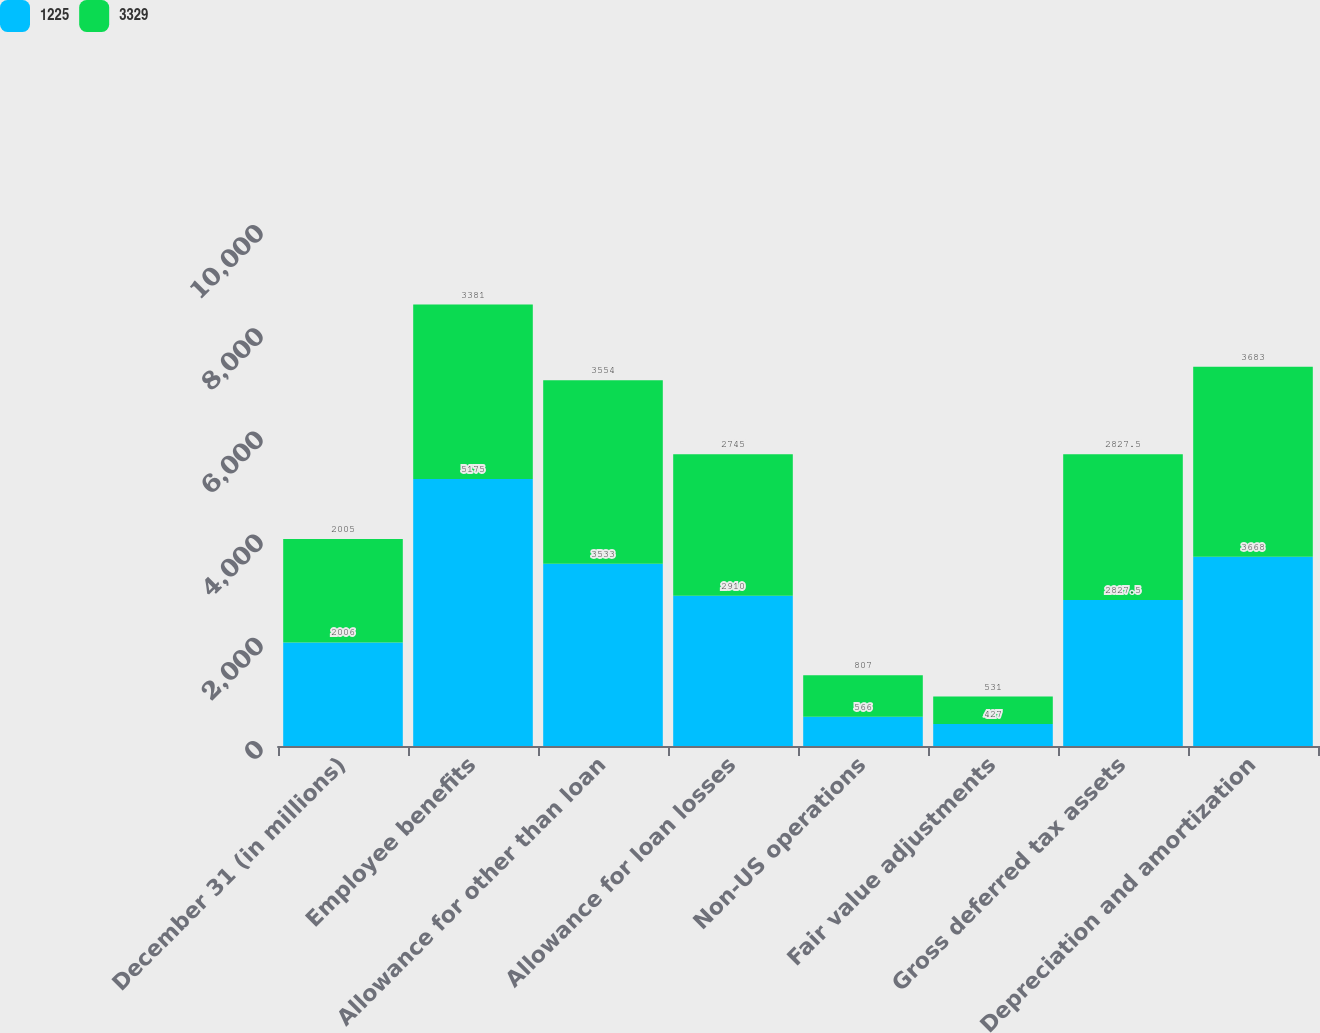<chart> <loc_0><loc_0><loc_500><loc_500><stacked_bar_chart><ecel><fcel>December 31 (in millions)<fcel>Employee benefits<fcel>Allowance for other than loan<fcel>Allowance for loan losses<fcel>Non-US operations<fcel>Fair value adjustments<fcel>Gross deferred tax assets<fcel>Depreciation and amortization<nl><fcel>1225<fcel>2006<fcel>5175<fcel>3533<fcel>2910<fcel>566<fcel>427<fcel>2827.5<fcel>3668<nl><fcel>3329<fcel>2005<fcel>3381<fcel>3554<fcel>2745<fcel>807<fcel>531<fcel>2827.5<fcel>3683<nl></chart> 